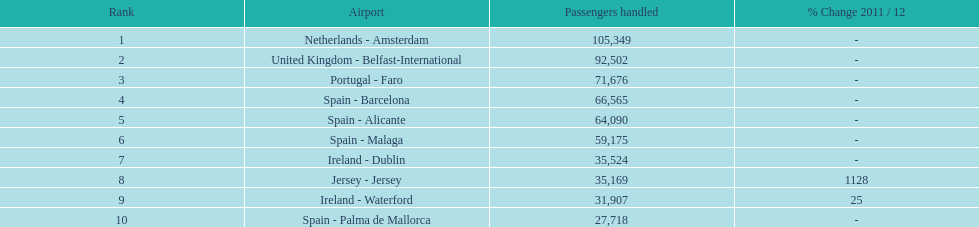Looking at the top 10 busiest routes to and from london southend airport what is the average number of passengers handled? 58,967.5. 